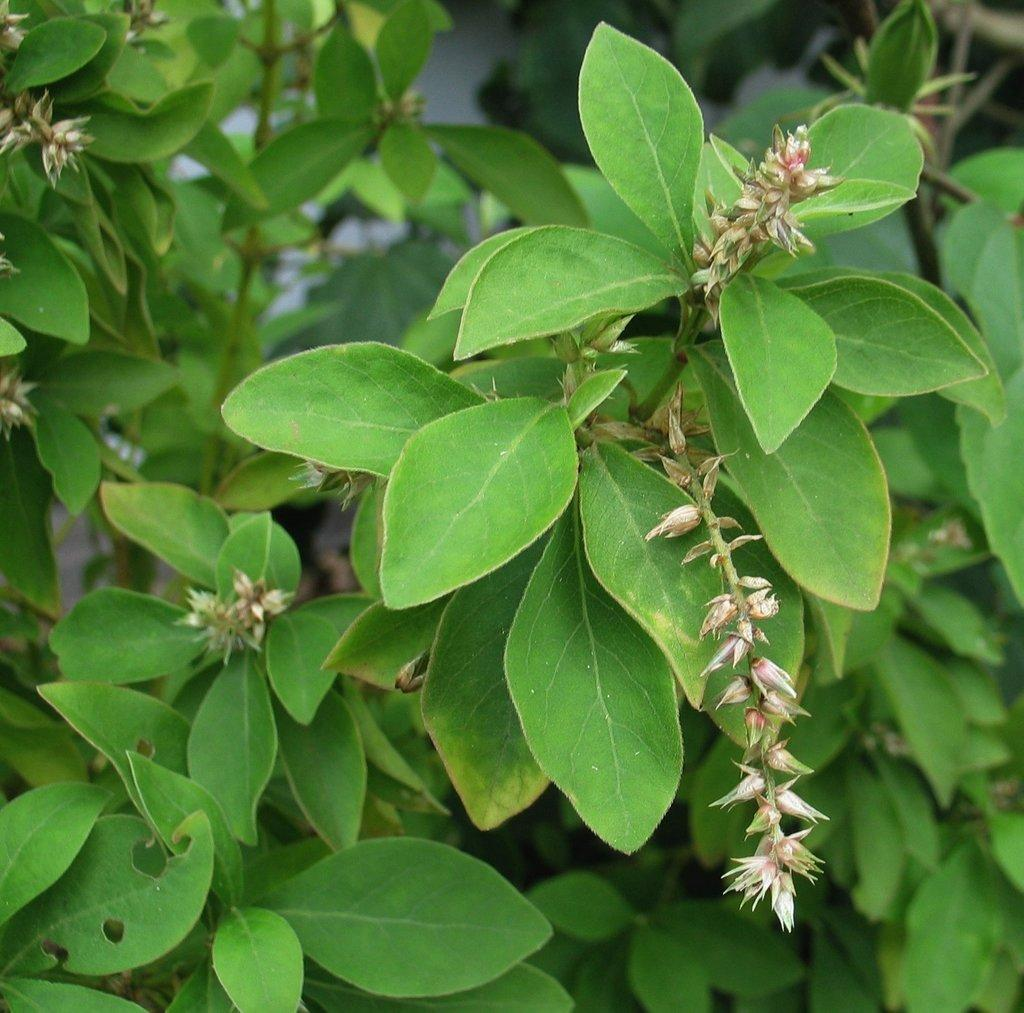What type of vegetation can be seen in the image? There are many plants in the image. What specific parts of the plants are visible? Leaves are present in the image. Are there any flowers visible among the plants? Yes, flowers are visible in the image. How would you describe the background of the image? The background of the image is blurry. Can you see any ladybugs flying around the plants in the image? There is no mention of ladybugs in the image, so we cannot determine if any are present. 